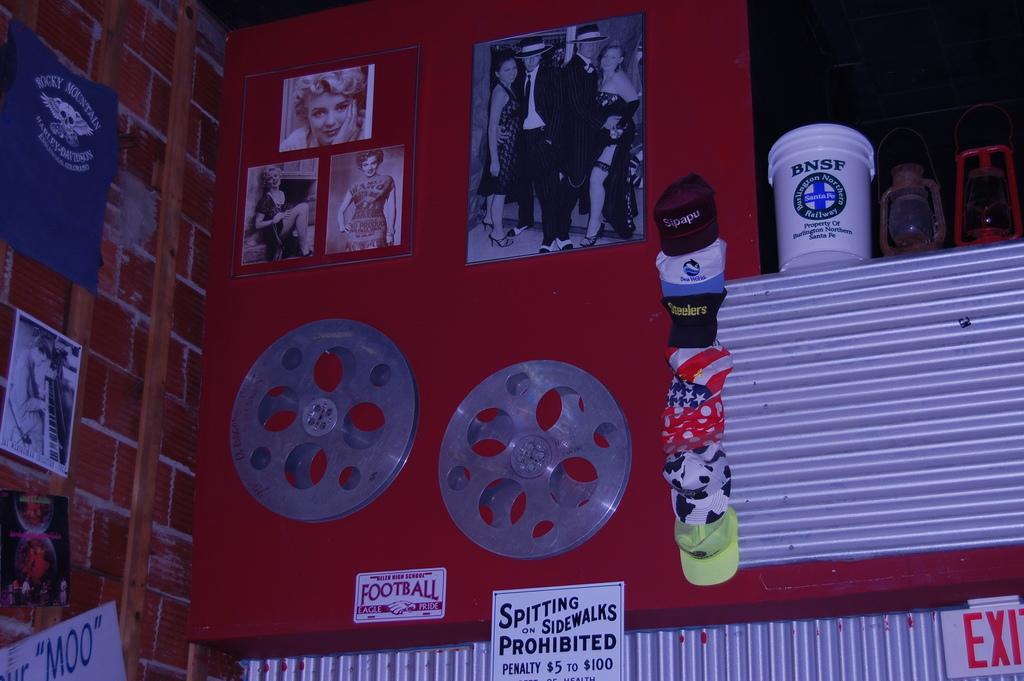What is prohibited?
Make the answer very short. Spitting on sidewalks. For which sport is there eagle pride?
Offer a very short reply. Football. 